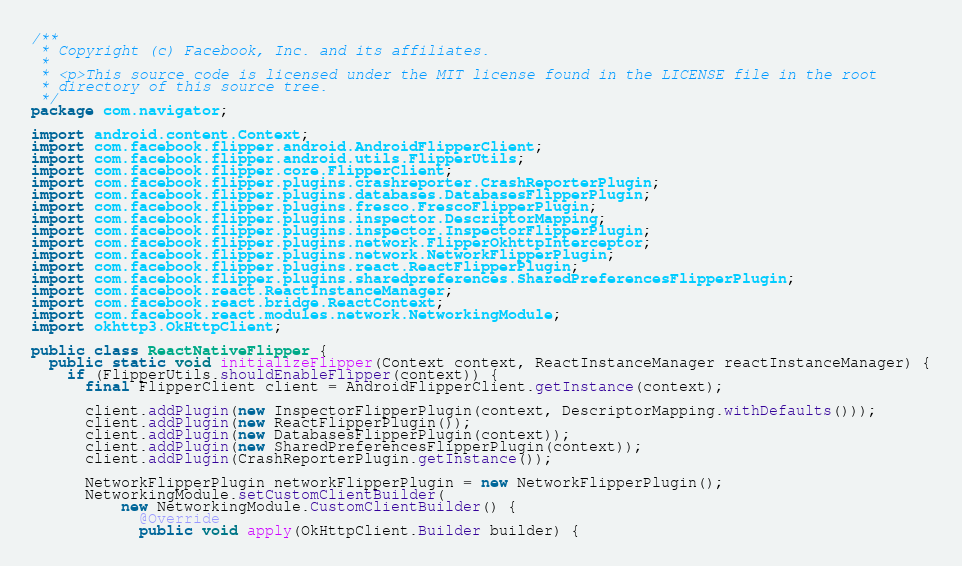<code> <loc_0><loc_0><loc_500><loc_500><_Java_>/**
 * Copyright (c) Facebook, Inc. and its affiliates.
 *
 * <p>This source code is licensed under the MIT license found in the LICENSE file in the root
 * directory of this source tree.
 */
package com.navigator;

import android.content.Context;
import com.facebook.flipper.android.AndroidFlipperClient;
import com.facebook.flipper.android.utils.FlipperUtils;
import com.facebook.flipper.core.FlipperClient;
import com.facebook.flipper.plugins.crashreporter.CrashReporterPlugin;
import com.facebook.flipper.plugins.databases.DatabasesFlipperPlugin;
import com.facebook.flipper.plugins.fresco.FrescoFlipperPlugin;
import com.facebook.flipper.plugins.inspector.DescriptorMapping;
import com.facebook.flipper.plugins.inspector.InspectorFlipperPlugin;
import com.facebook.flipper.plugins.network.FlipperOkhttpInterceptor;
import com.facebook.flipper.plugins.network.NetworkFlipperPlugin;
import com.facebook.flipper.plugins.react.ReactFlipperPlugin;
import com.facebook.flipper.plugins.sharedpreferences.SharedPreferencesFlipperPlugin;
import com.facebook.react.ReactInstanceManager;
import com.facebook.react.bridge.ReactContext;
import com.facebook.react.modules.network.NetworkingModule;
import okhttp3.OkHttpClient;

public class ReactNativeFlipper {
  public static void initializeFlipper(Context context, ReactInstanceManager reactInstanceManager) {
    if (FlipperUtils.shouldEnableFlipper(context)) {
      final FlipperClient client = AndroidFlipperClient.getInstance(context);

      client.addPlugin(new InspectorFlipperPlugin(context, DescriptorMapping.withDefaults()));
      client.addPlugin(new ReactFlipperPlugin());
      client.addPlugin(new DatabasesFlipperPlugin(context));
      client.addPlugin(new SharedPreferencesFlipperPlugin(context));
      client.addPlugin(CrashReporterPlugin.getInstance());

      NetworkFlipperPlugin networkFlipperPlugin = new NetworkFlipperPlugin();
      NetworkingModule.setCustomClientBuilder(
          new NetworkingModule.CustomClientBuilder() {
            @Override
            public void apply(OkHttpClient.Builder builder) {</code> 